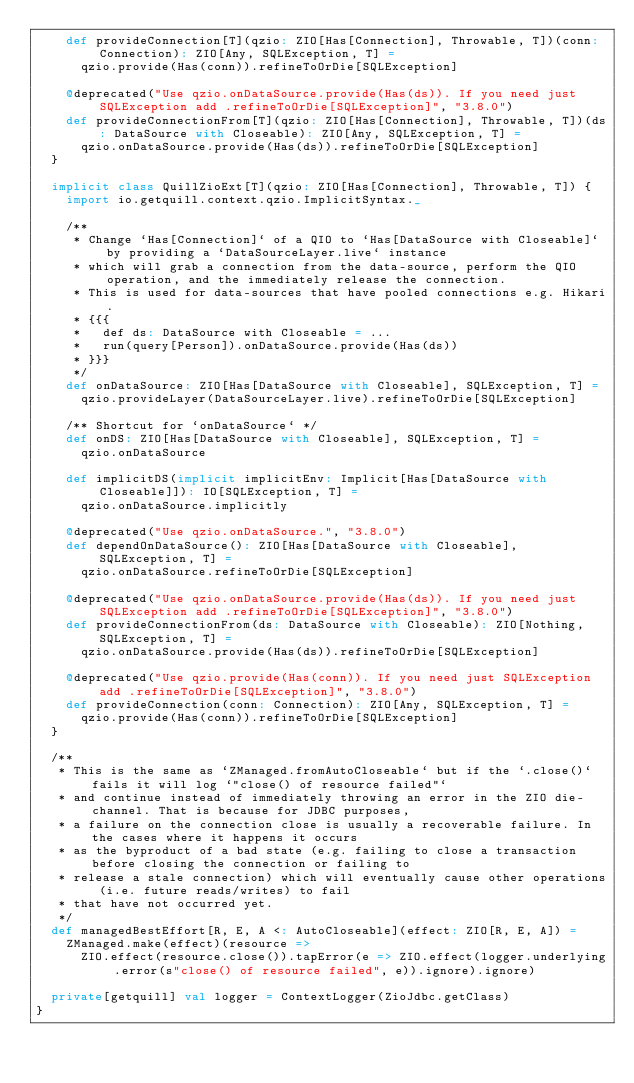<code> <loc_0><loc_0><loc_500><loc_500><_Scala_>    def provideConnection[T](qzio: ZIO[Has[Connection], Throwable, T])(conn: Connection): ZIO[Any, SQLException, T] =
      qzio.provide(Has(conn)).refineToOrDie[SQLException]

    @deprecated("Use qzio.onDataSource.provide(Has(ds)). If you need just SQLException add .refineToOrDie[SQLException]", "3.8.0")
    def provideConnectionFrom[T](qzio: ZIO[Has[Connection], Throwable, T])(ds: DataSource with Closeable): ZIO[Any, SQLException, T] =
      qzio.onDataSource.provide(Has(ds)).refineToOrDie[SQLException]
  }

  implicit class QuillZioExt[T](qzio: ZIO[Has[Connection], Throwable, T]) {
    import io.getquill.context.qzio.ImplicitSyntax._

    /**
     * Change `Has[Connection]` of a QIO to `Has[DataSource with Closeable]` by providing a `DataSourceLayer.live` instance
     * which will grab a connection from the data-source, perform the QIO operation, and the immediately release the connection.
     * This is used for data-sources that have pooled connections e.g. Hikari.
     * {{{
     *   def ds: DataSource with Closeable = ...
     *   run(query[Person]).onDataSource.provide(Has(ds))
     * }}}
     */
    def onDataSource: ZIO[Has[DataSource with Closeable], SQLException, T] =
      qzio.provideLayer(DataSourceLayer.live).refineToOrDie[SQLException]

    /** Shortcut for `onDataSource` */
    def onDS: ZIO[Has[DataSource with Closeable], SQLException, T] =
      qzio.onDataSource

    def implicitDS(implicit implicitEnv: Implicit[Has[DataSource with Closeable]]): IO[SQLException, T] =
      qzio.onDataSource.implicitly

    @deprecated("Use qzio.onDataSource.", "3.8.0")
    def dependOnDataSource(): ZIO[Has[DataSource with Closeable], SQLException, T] =
      qzio.onDataSource.refineToOrDie[SQLException]

    @deprecated("Use qzio.onDataSource.provide(Has(ds)). If you need just SQLException add .refineToOrDie[SQLException]", "3.8.0")
    def provideConnectionFrom(ds: DataSource with Closeable): ZIO[Nothing, SQLException, T] =
      qzio.onDataSource.provide(Has(ds)).refineToOrDie[SQLException]

    @deprecated("Use qzio.provide(Has(conn)). If you need just SQLException add .refineToOrDie[SQLException]", "3.8.0")
    def provideConnection(conn: Connection): ZIO[Any, SQLException, T] =
      qzio.provide(Has(conn)).refineToOrDie[SQLException]
  }

  /**
   * This is the same as `ZManaged.fromAutoCloseable` but if the `.close()` fails it will log `"close() of resource failed"`
   * and continue instead of immediately throwing an error in the ZIO die-channel. That is because for JDBC purposes,
   * a failure on the connection close is usually a recoverable failure. In the cases where it happens it occurs
   * as the byproduct of a bad state (e.g. failing to close a transaction before closing the connection or failing to
   * release a stale connection) which will eventually cause other operations (i.e. future reads/writes) to fail
   * that have not occurred yet.
   */
  def managedBestEffort[R, E, A <: AutoCloseable](effect: ZIO[R, E, A]) =
    ZManaged.make(effect)(resource =>
      ZIO.effect(resource.close()).tapError(e => ZIO.effect(logger.underlying.error(s"close() of resource failed", e)).ignore).ignore)

  private[getquill] val logger = ContextLogger(ZioJdbc.getClass)
}
</code> 